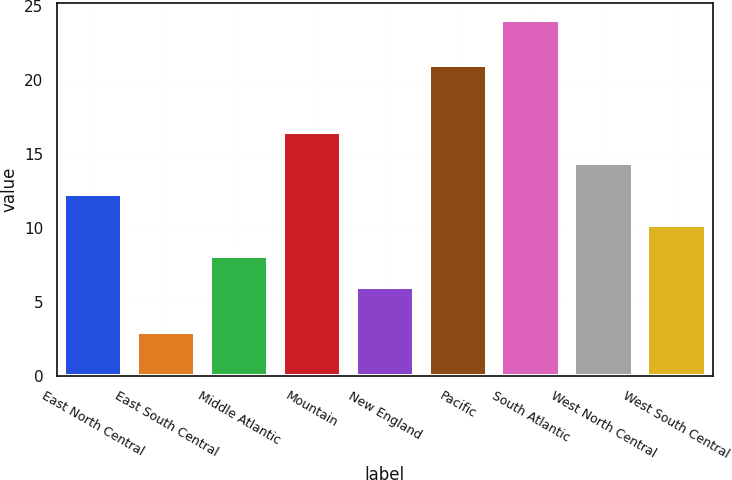<chart> <loc_0><loc_0><loc_500><loc_500><bar_chart><fcel>East North Central<fcel>East South Central<fcel>Middle Atlantic<fcel>Mountain<fcel>New England<fcel>Pacific<fcel>South Atlantic<fcel>West North Central<fcel>West South Central<nl><fcel>12.3<fcel>3<fcel>8.1<fcel>16.5<fcel>6<fcel>21<fcel>24<fcel>14.4<fcel>10.2<nl></chart> 